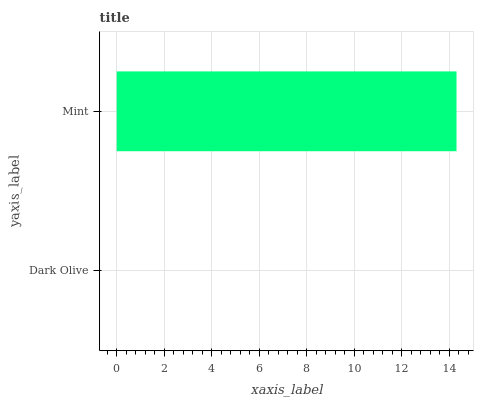Is Dark Olive the minimum?
Answer yes or no. Yes. Is Mint the maximum?
Answer yes or no. Yes. Is Mint the minimum?
Answer yes or no. No. Is Mint greater than Dark Olive?
Answer yes or no. Yes. Is Dark Olive less than Mint?
Answer yes or no. Yes. Is Dark Olive greater than Mint?
Answer yes or no. No. Is Mint less than Dark Olive?
Answer yes or no. No. Is Mint the high median?
Answer yes or no. Yes. Is Dark Olive the low median?
Answer yes or no. Yes. Is Dark Olive the high median?
Answer yes or no. No. Is Mint the low median?
Answer yes or no. No. 